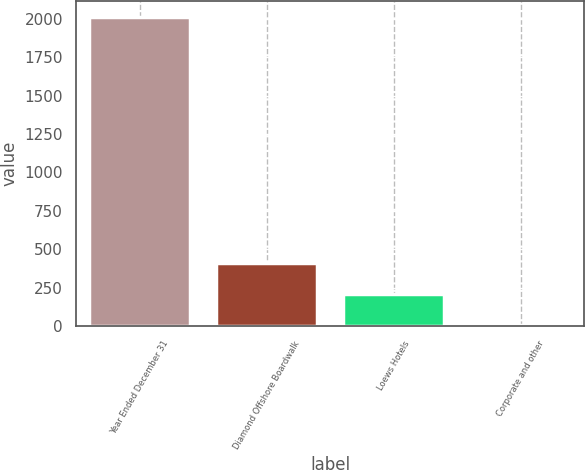Convert chart. <chart><loc_0><loc_0><loc_500><loc_500><bar_chart><fcel>Year Ended December 31<fcel>Diamond Offshore Boardwalk<fcel>Loews Hotels<fcel>Corporate and other<nl><fcel>2014<fcel>407.6<fcel>206.8<fcel>6<nl></chart> 